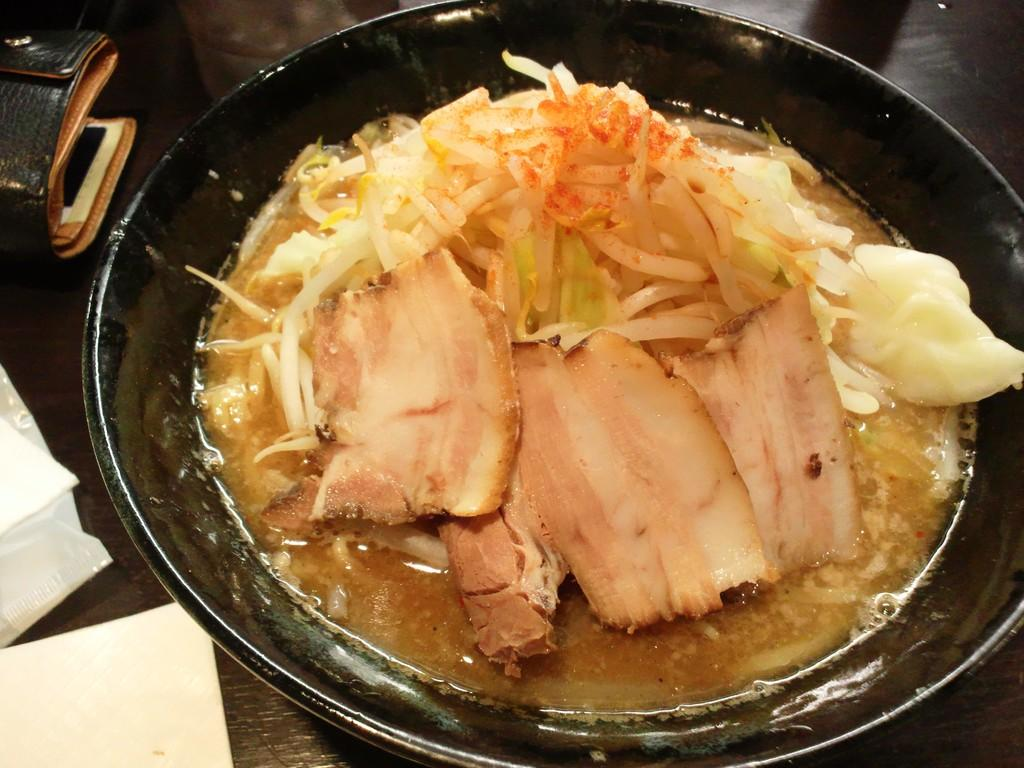What is the main food item placed in a dish in the image? The specific food item is not mentioned, but there is a food item placed in a dish in the image. What is the color of the surface the dish is placed on? The dish is on a black color surface. What can be used for cleaning or wiping in the image? Tissues are present in the image for cleaning or wiping. What accessory is visible in the image? There is a purse in the image. What type of pin can be seen holding the food item in the image? There is no pin present in the image; the food item is placed in a dish. 